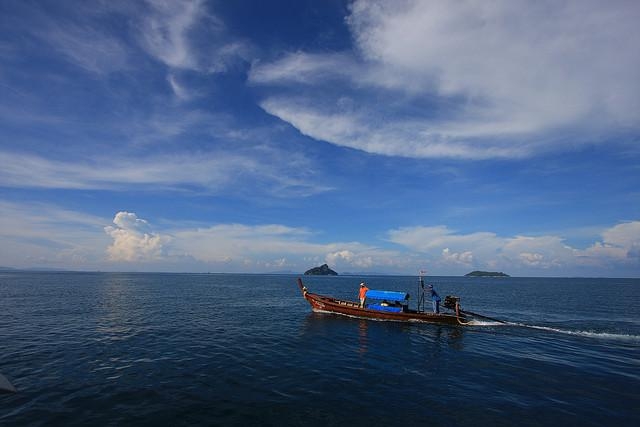What propels this craft forward?

Choices:
A) oars
B) sails
C) motor
D) wind motor 